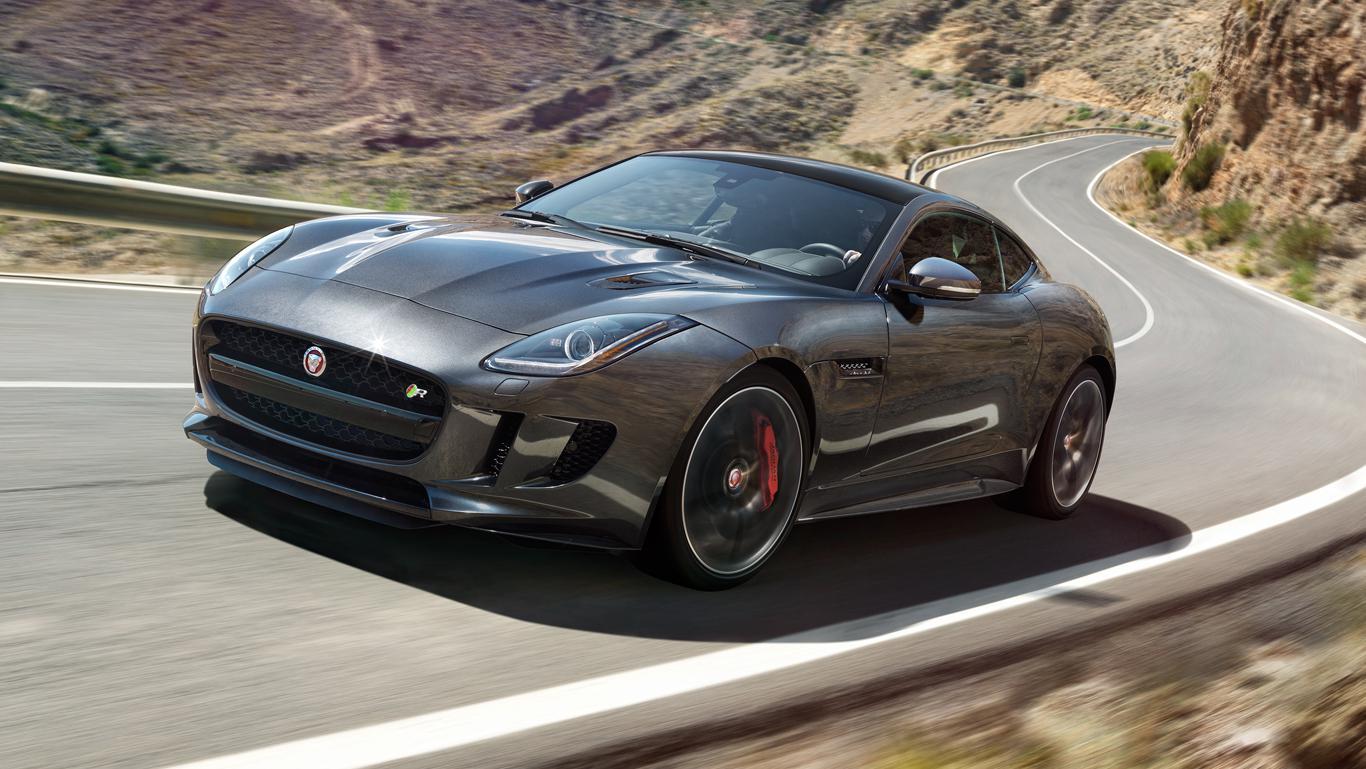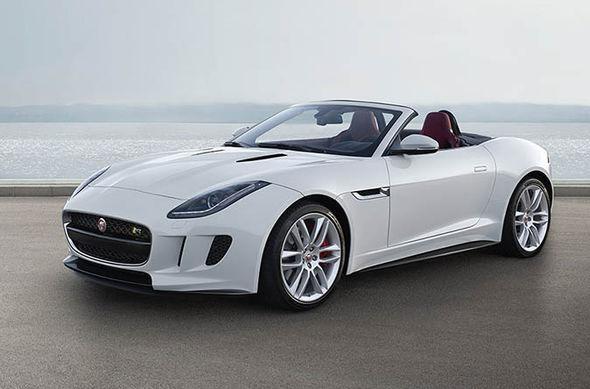The first image is the image on the left, the second image is the image on the right. Given the left and right images, does the statement "There is one car with its top down and one car with the top up" hold true? Answer yes or no. Yes. The first image is the image on the left, the second image is the image on the right. For the images displayed, is the sentence "The cars in the left and right images face the same direction, but one has its top up and one has its top down." factually correct? Answer yes or no. Yes. 